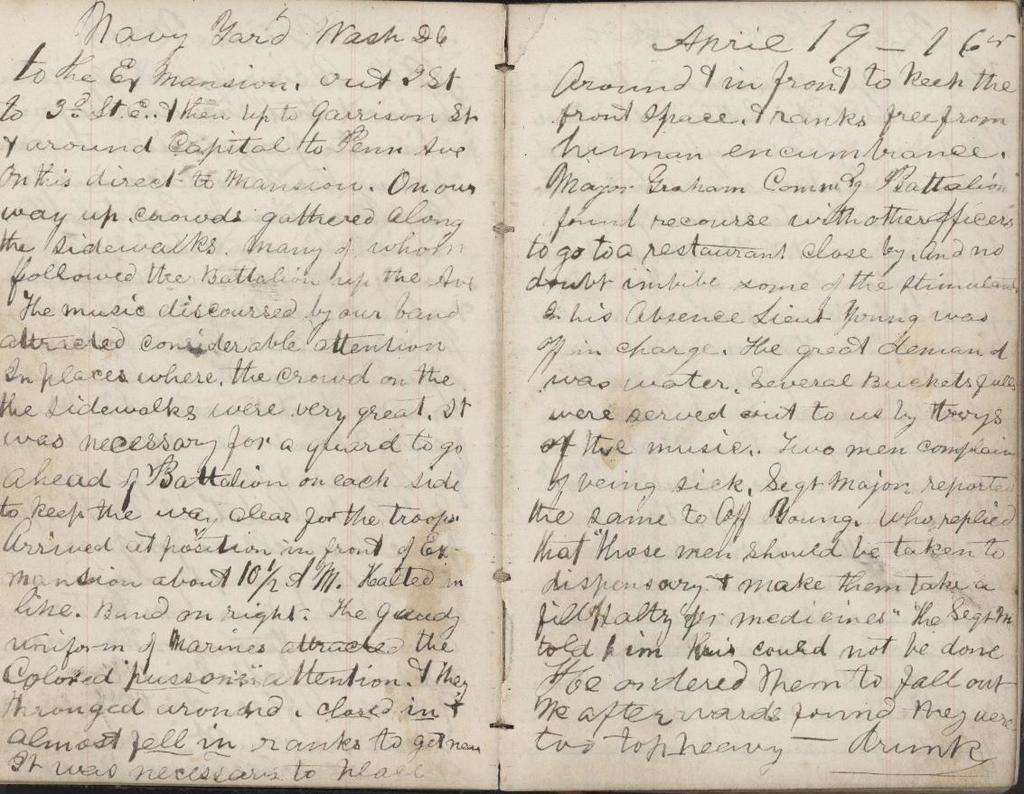<image>
Share a concise interpretation of the image provided. A dairy entry from April 19th at the Navy Yard in Washington, D.C. 